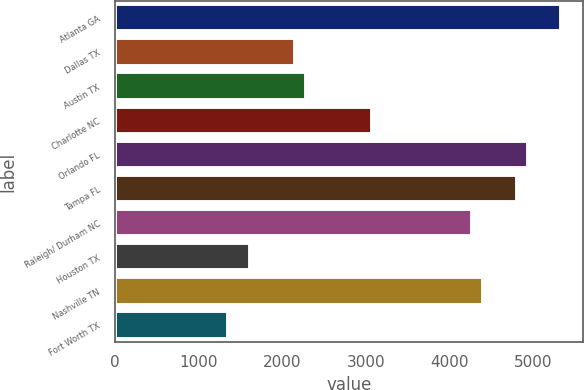<chart> <loc_0><loc_0><loc_500><loc_500><bar_chart><fcel>Atlanta GA<fcel>Dallas TX<fcel>Austin TX<fcel>Charlotte NC<fcel>Orlando FL<fcel>Tampa FL<fcel>Raleigh/ Durham NC<fcel>Houston TX<fcel>Nashville TN<fcel>Fort Worth TX<nl><fcel>5328.92<fcel>2145.8<fcel>2278.43<fcel>3074.21<fcel>4931.03<fcel>4798.4<fcel>4267.88<fcel>1615.28<fcel>4400.51<fcel>1350.02<nl></chart> 